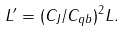<formula> <loc_0><loc_0><loc_500><loc_500>L ^ { \prime } = ( C _ { J } / C _ { q b } ) ^ { 2 } L .</formula> 